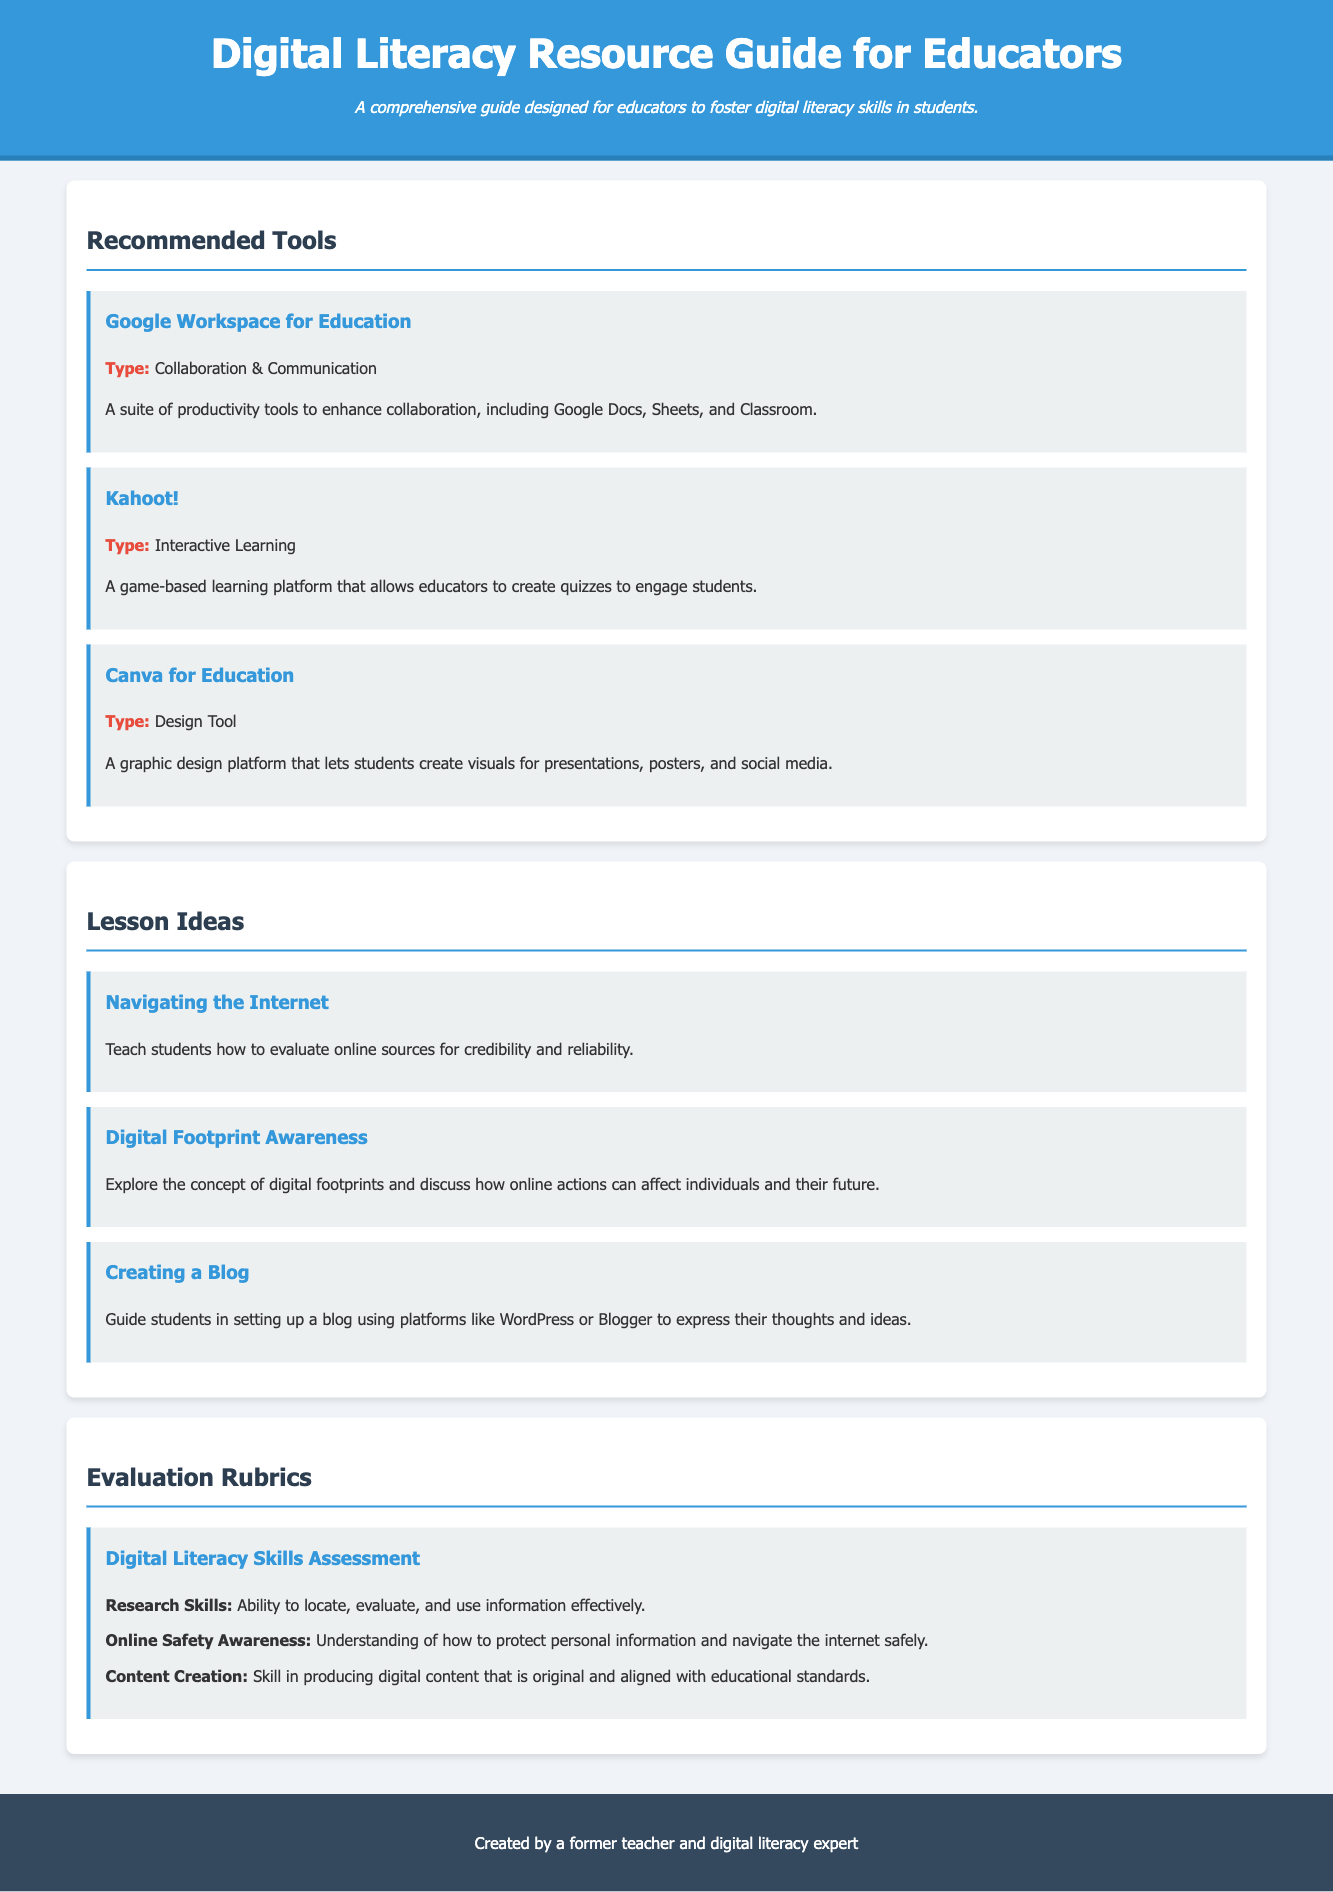What is the title of the document? The title of the document is prominently displayed at the top of the rendered page.
Answer: Digital Literacy Resource Guide for Educators How many recommended tools are listed? The document section describes three tools, which can be counted.
Answer: 3 What type of tool is Kahoot!? The type of tool is mentioned directly under its name in the description section.
Answer: Interactive Learning What is one lesson idea mentioned in the document? The document lists several lesson ideas, any one of which can be listed as an answer.
Answer: Navigating the Internet What is the focus of the Digital Literacy Skills Assessment rubric? The document specifies key skills that the rubric assesses.
Answer: Research Skills Which platform is suggested for creating a blog? The document mentions specific platforms that can be used to create a blog.
Answer: WordPress How many evaluation rubric categories are listed? The document contains a list that can be counted for the number of categories.
Answer: 3 Who created the resource guide? The footer of the document states the individual responsible for creating the guide.
Answer: A former teacher and digital literacy expert 